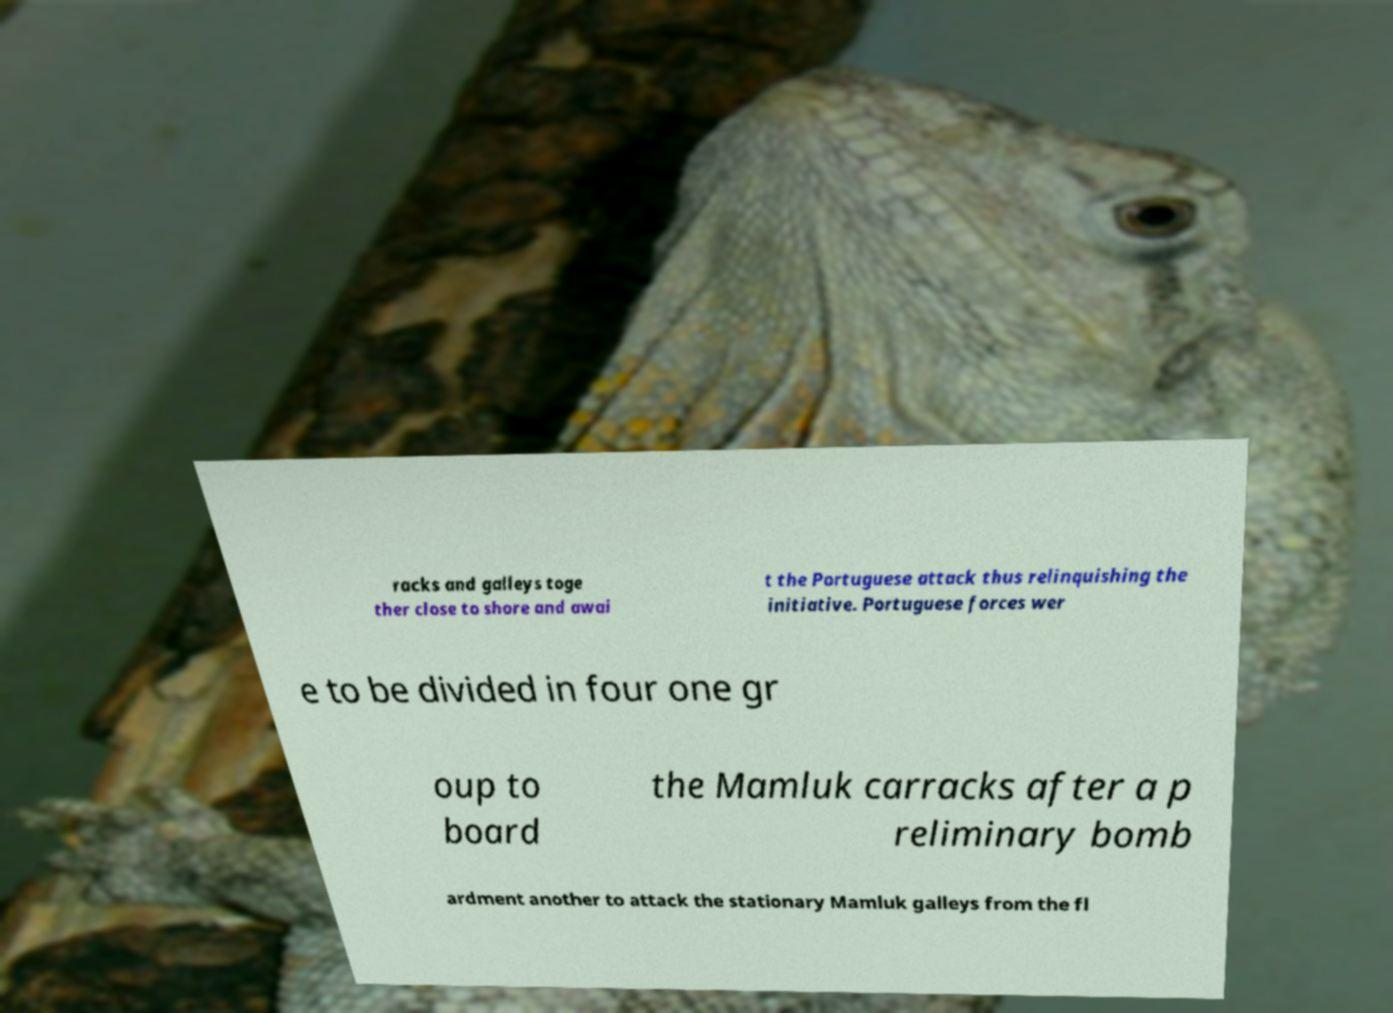Could you extract and type out the text from this image? racks and galleys toge ther close to shore and awai t the Portuguese attack thus relinquishing the initiative. Portuguese forces wer e to be divided in four one gr oup to board the Mamluk carracks after a p reliminary bomb ardment another to attack the stationary Mamluk galleys from the fl 